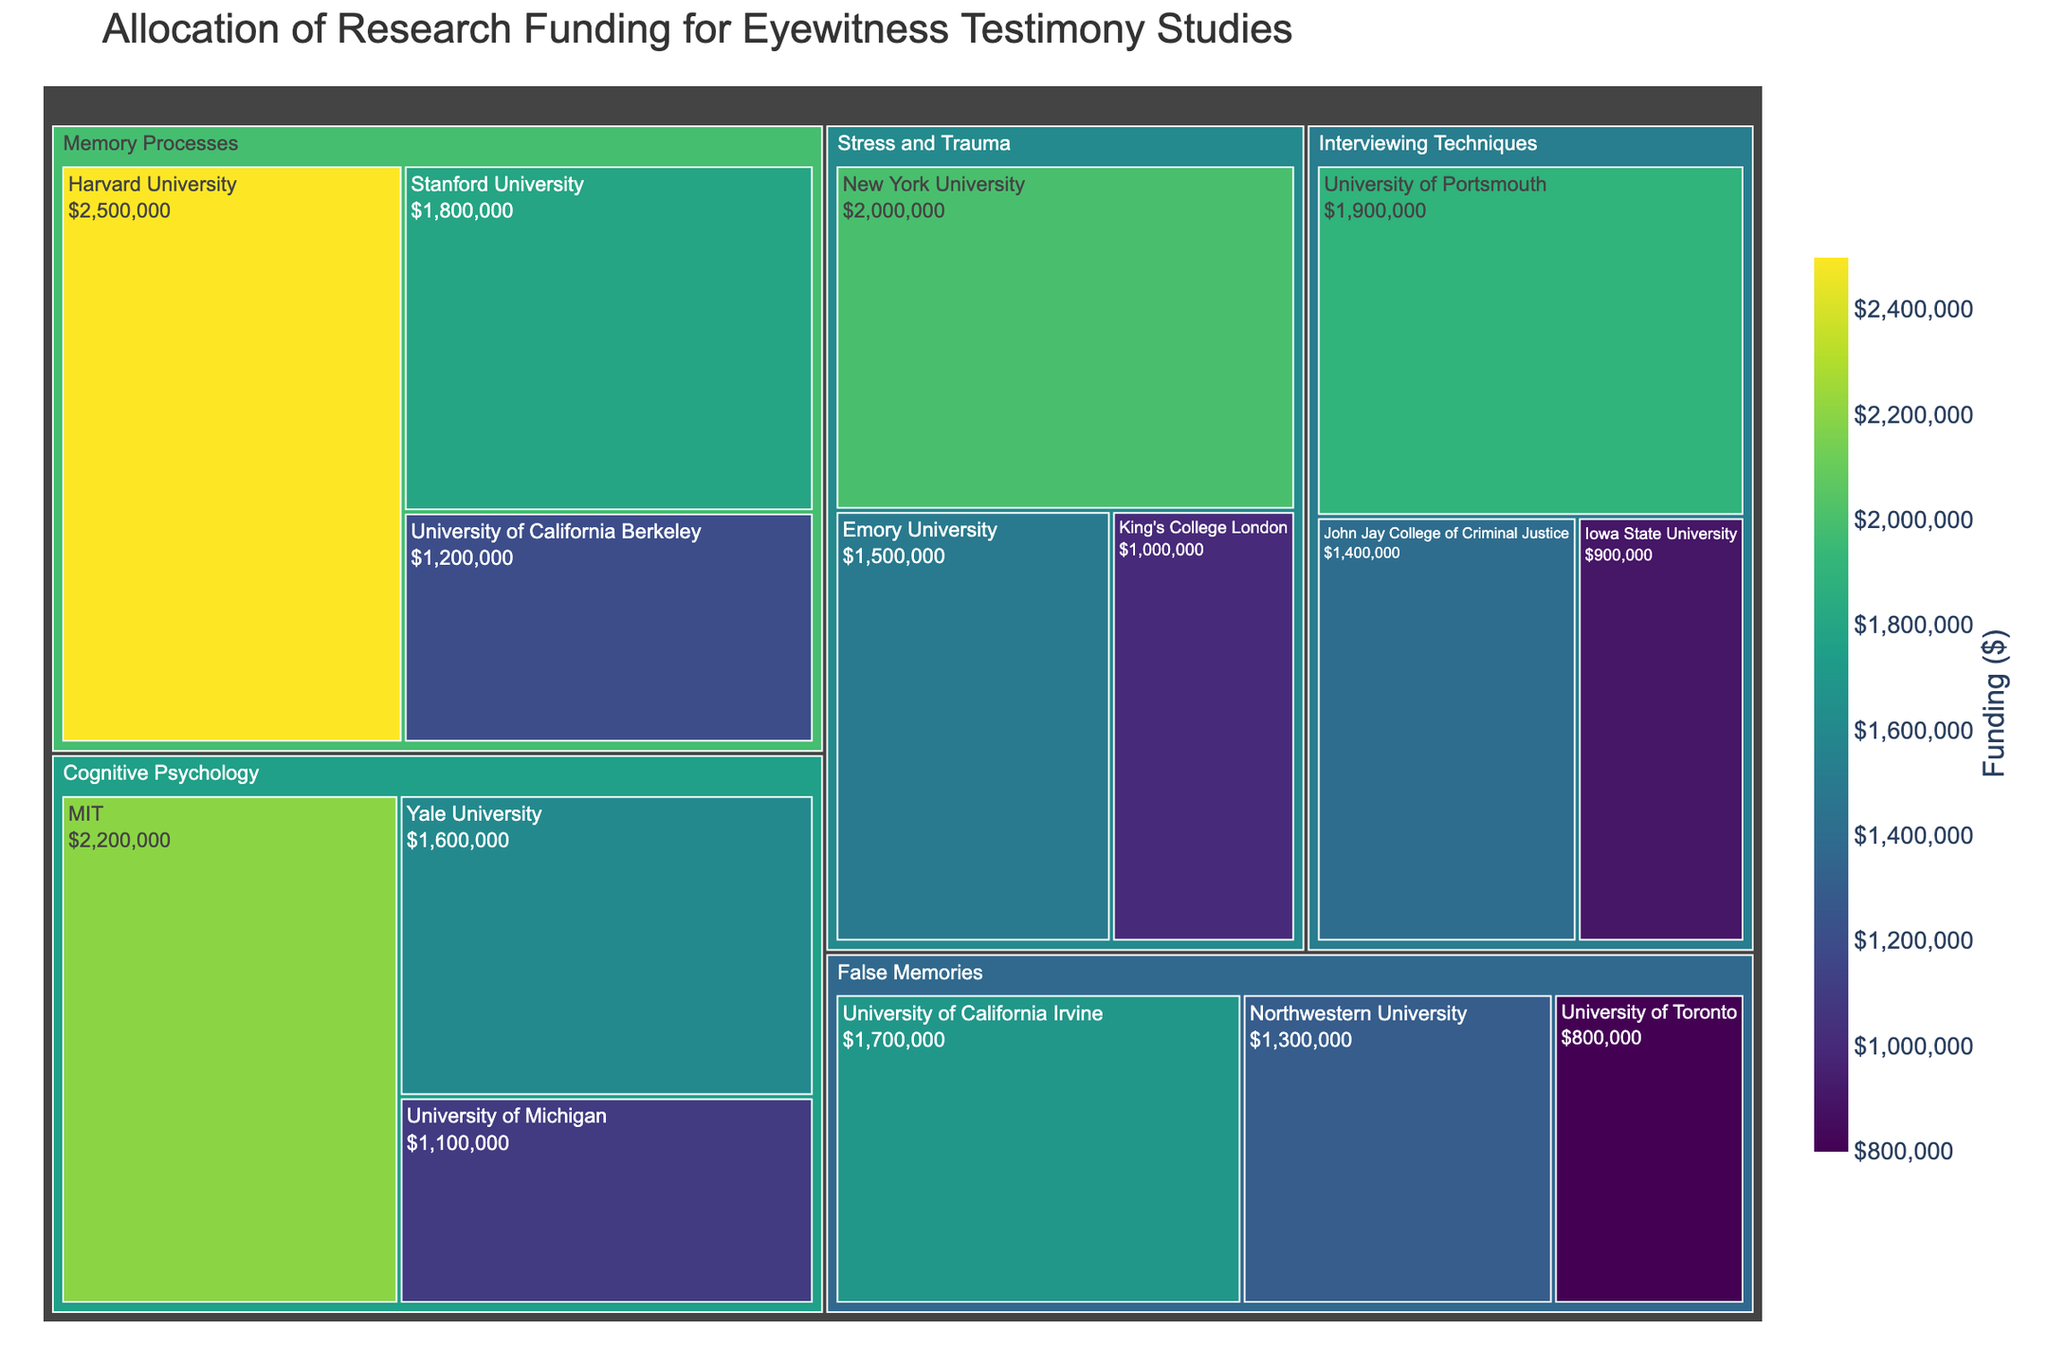What is the title of the treemap? The title can be found at the top of the diagram and summarizes the content of the treemap.
Answer: Allocation of Research Funding for Eyewitness Testimony Studies Which subfield received the highest total funding? By examining the size and color of the regions representing each subfield in the treemap, the subfield with the largest block and the darkest color will indicate the highest funding.
Answer: Memory Processes How much funding did Harvard University receive for its research in Memory Processes? By locating Harvard University within the Memory Processes subfield on the treemap, you can see the funding amount displayed.
Answer: $2,500,000 What is the combined funding for the Cognitive Psychology subfield? Sum the funding amounts of all institutions under Cognitive Psychology shown in the treemap: MIT ($2,200,000), Yale University ($1,600,000), University of Michigan ($1,100,000).
Answer: $4,900,000 Which institution within the Interviewing Techniques subfield received the lowest funding, and how much was it? Find the smallest rectangle within the Interviewing Techniques subfield and read both the institution name and the funding amount from the treemap.
Answer: Iowa State University, $900,000 Compare the funding received by MIT and New York University. Which institution received more, and by how much? Evaluate the funding amounts for MIT ($2,200,000) and New York University ($2,000,000), then calculate the difference.
Answer: MIT received $200,000 more than New York University What percentage of the total funding for Interviewing Techniques did the University of Portsmouth receive? First, sum the funding for all institutions in Interviewing Techniques: University of Portsmouth ($1,900,000), John Jay College of Criminal Justice ($1,400,000), Iowa State University ($900,000). Then, calculate the percentage for the University of Portsmouth by dividing its funding by the total and multiplying by 100.
Answer: 42.22% Among all the institutions, which one received the highest single funding amount, and which subfield does it belong to? Identify the largest single rectangle in the entire treemap and read the associated institution and subfield.
Answer: Harvard University, Memory Processes Within the False Memories subfield, what is the difference in funding between the highest and lowest funded institutions? Identify the highest ($1,700,000, University of California Irvine) and lowest ($800,000, University of Toronto) funded institutions, and calculate the difference.
Answer: $900,000 How does the average funding for institutions in the Stress and Trauma subfield compare to that in the False Memories subfield? Calculate the average funding for each subfield by summing the amounts and dividing by the number of institutions. Compare the averages: Stress and Trauma: (New York University ($2,000,000) + Emory University ($1,500,000) + King's College London ($1,000,000)) / 3. False Memories: (University of California Irvine ($1,700,000) + Northwestern University ($1,300,000) + University of Toronto ($800,000)) / 3.
Answer: Stress and Trauma: $1,500,000; False Memories: $1,266,666; Stress and Trauma has a higher average 